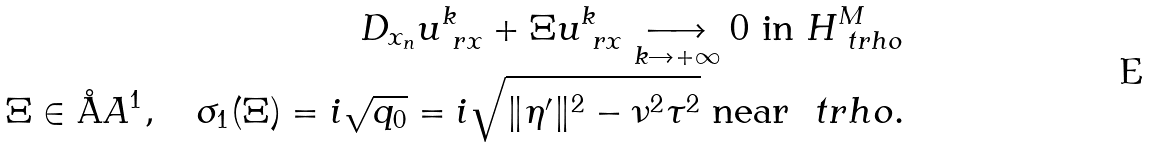<formula> <loc_0><loc_0><loc_500><loc_500>D _ { x _ { n } } u ^ { k } _ { \ r x } + \Xi u ^ { k } _ { \ r x } \underset { k \rightarrow + \infty } \longrightarrow 0 \text { in } H ^ { M } _ { \ t r h o } \\ \Xi \in \AA A ^ { 1 } , \quad \sigma _ { 1 } ( \Xi ) = i \sqrt { q _ { 0 } } = i \sqrt { \| \eta ^ { \prime } \| ^ { 2 } - \nu ^ { 2 } \tau ^ { 2 } } \text { near } \ t r h o .</formula> 